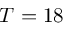Convert formula to latex. <formula><loc_0><loc_0><loc_500><loc_500>T = 1 8</formula> 